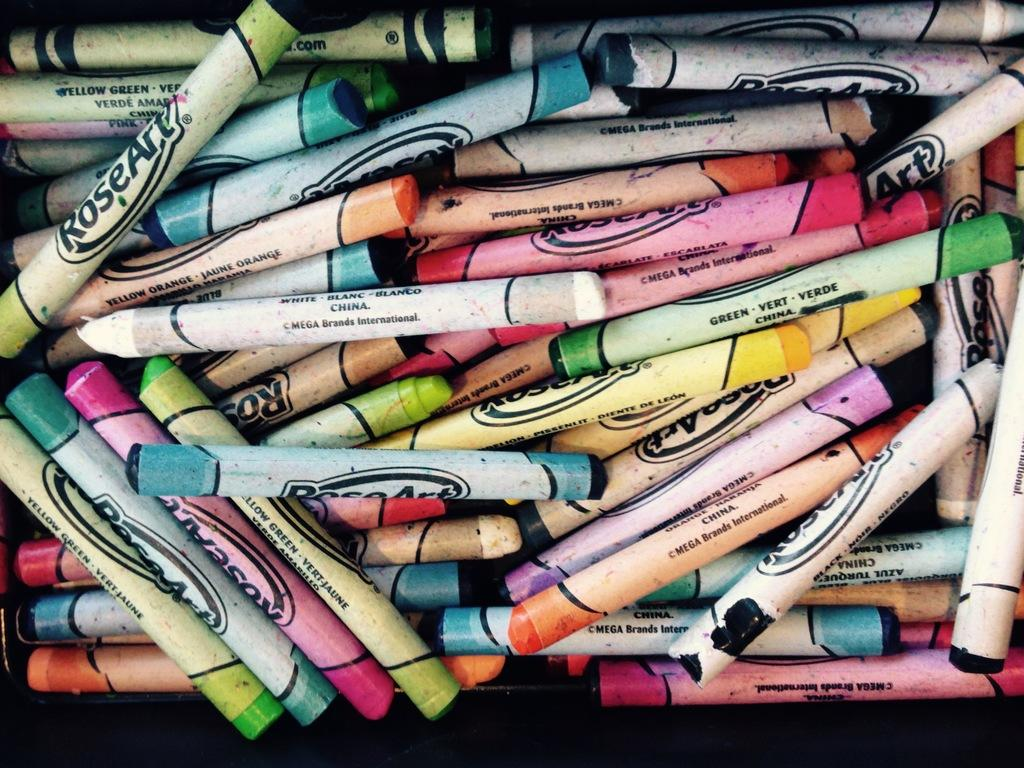What objects are present in the image? There are crayons in the image. What might the crayons be used for? The crayons might be used for drawing or coloring. Are the crayons arranged in any particular pattern or order? The provided facts do not mention any specific arrangement of the crayons. What type of bell can be heard ringing in the image? There is no bell present in the image, so it is not possible to hear a bell ringing. 